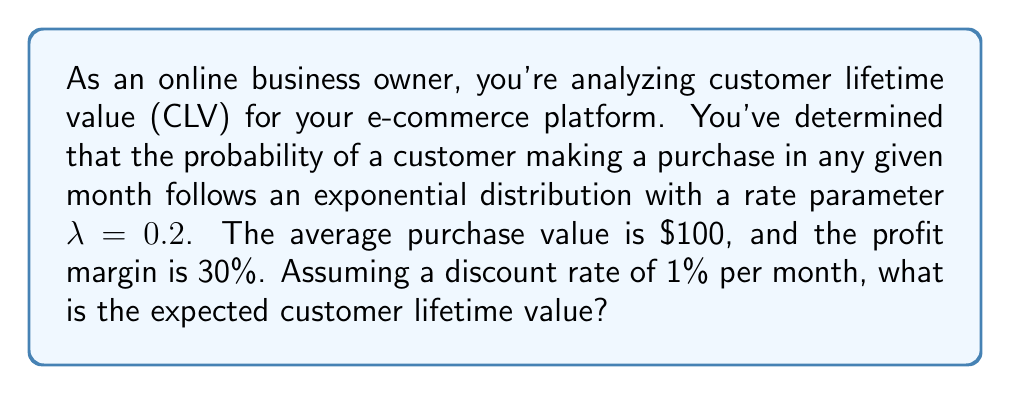Provide a solution to this math problem. To solve this problem, we'll follow these steps:

1) First, let's recall the formula for expected customer lifetime value (CLV):

   $$ CLV = \frac{m \cdot f}{r - g} $$

   Where:
   $m$ = margin per purchase
   $f$ = purchase frequency (purchases per month)
   $r$ = monthly discount rate
   $g$ = monthly growth rate (which we'll assume is 0 for this problem)

2) We know the following:
   - Profit margin = 30% = 0.3
   - Average purchase value = $100
   - Discount rate = 1% per month = 0.01
   - $\lambda = 0.2$ (rate parameter for exponential distribution)

3) Calculate the margin per purchase:
   $m = 0.3 \cdot \$100 = \$30$

4) For the purchase frequency, we need to use the properties of the exponential distribution. The expected value (mean) of an exponential distribution is $\frac{1}{\lambda}$. This gives us the average time between purchases. To get purchases per month, we take the reciprocal:

   $f = \lambda = 0.2$ purchases per month

5) Now we can plug these values into our CLV formula:

   $$ CLV = \frac{\$30 \cdot 0.2}{0.01 - 0} = \frac{6}{0.01} = 600 $$

Therefore, the expected customer lifetime value is $600.
Answer: $600 